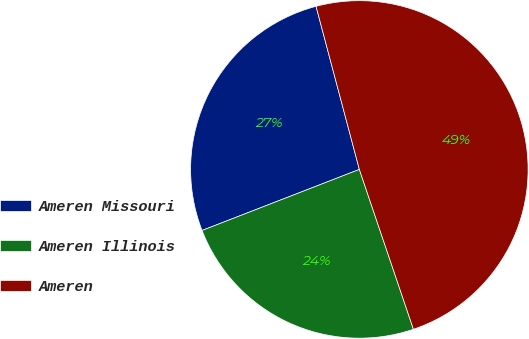Convert chart. <chart><loc_0><loc_0><loc_500><loc_500><pie_chart><fcel>Ameren Missouri<fcel>Ameren Illinois<fcel>Ameren<nl><fcel>26.76%<fcel>24.3%<fcel>48.94%<nl></chart> 